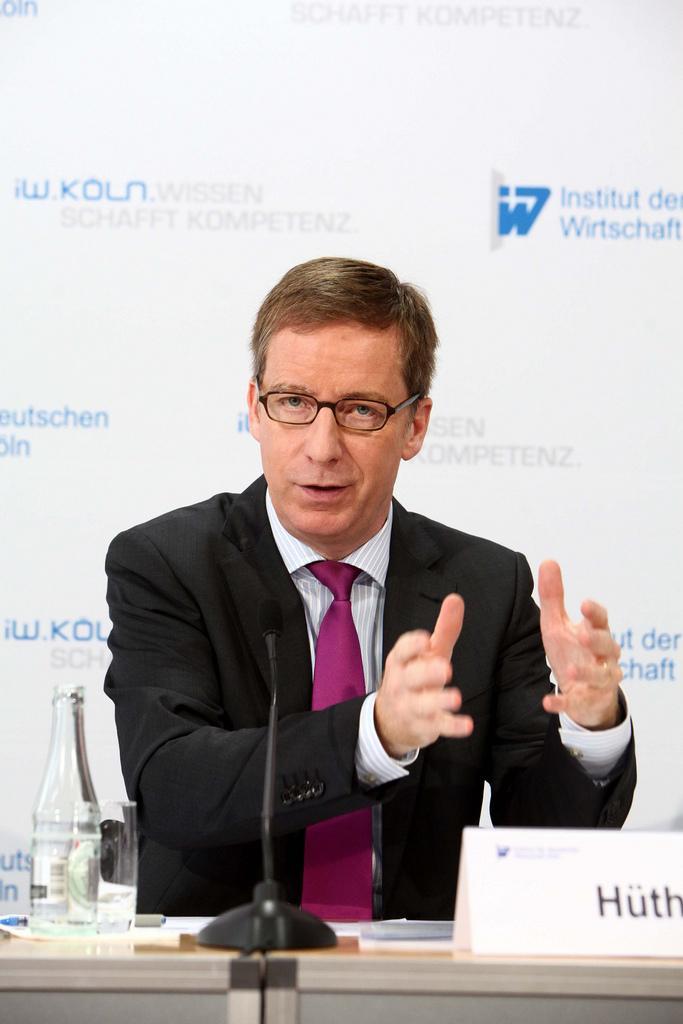In one or two sentences, can you explain what this image depicts? In this image there is a man sitting in chair and explaining ,and in table there is name board , microphone, bottle, glass, paper, pen ,and the back ground there is a hoarding. 